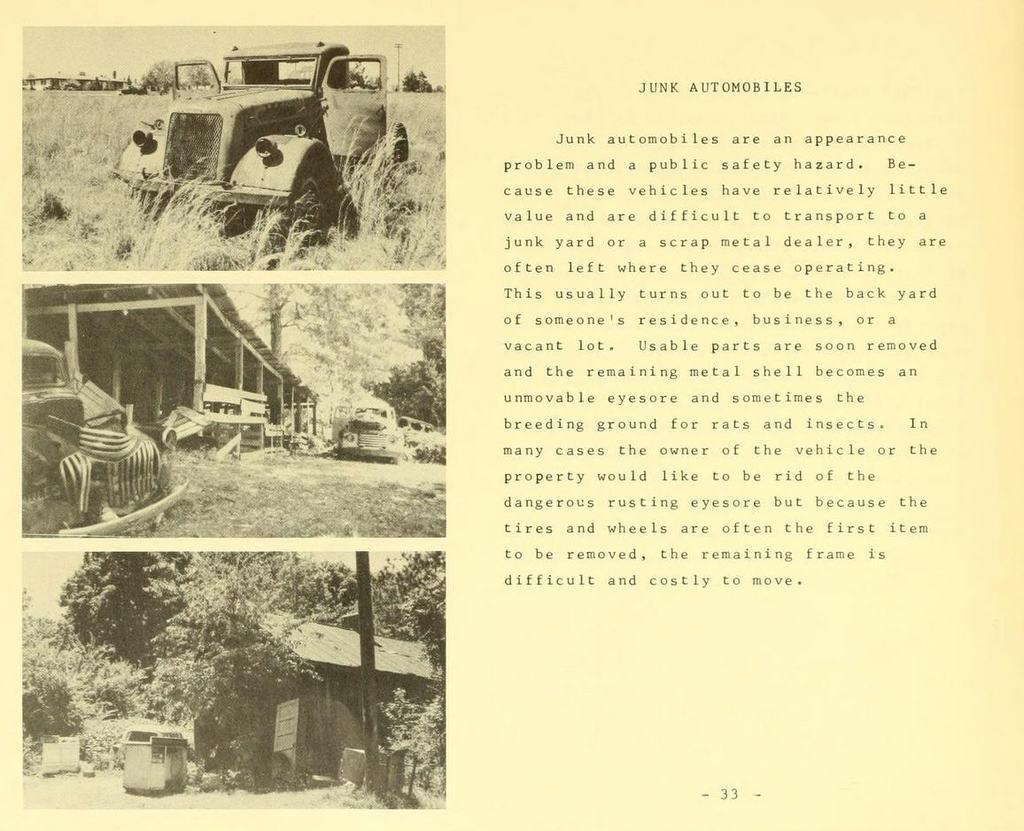What is the main subject of the paper in the image? The paper contains pictures of motor vehicles, sheds, trees, poles, and the sky. Can you describe the content of the paper in more detail? The paper contains pictures of motor vehicles, sheds, trees, poles, and the sky, as well as text on the right side of the paper. What type of produce can be seen growing on the poles in the image? There are no plants or produce visible in the image; the paper contains pictures of poles, but not growing produce. 